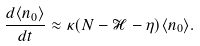Convert formula to latex. <formula><loc_0><loc_0><loc_500><loc_500>\frac { d \langle n _ { 0 } \rangle } { d t } \approx \kappa ( N - \mathcal { H } - \eta ) \langle n _ { 0 } \rangle .</formula> 